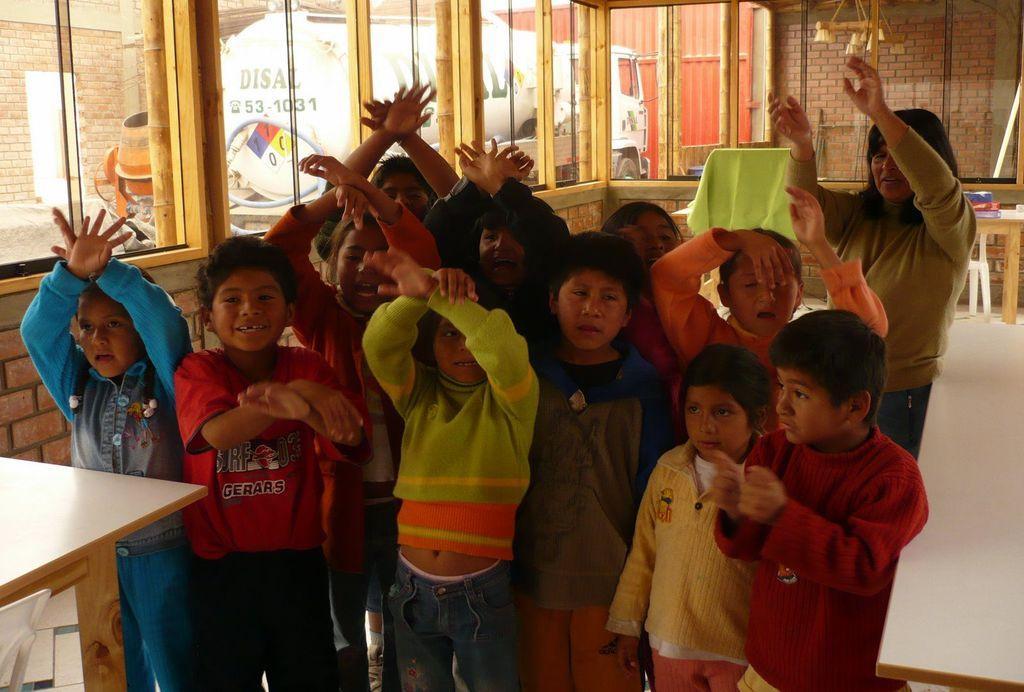In one or two sentences, can you explain what this image depicts? In the middle of the a few people are standing and smiling. Right side of the image a woman is standing and watching. Top right side of the image there is a brick wall. At the top of the image there is a vehicle. Bottom left side of the image there is a table. Bottom right of the image also there is a table. 